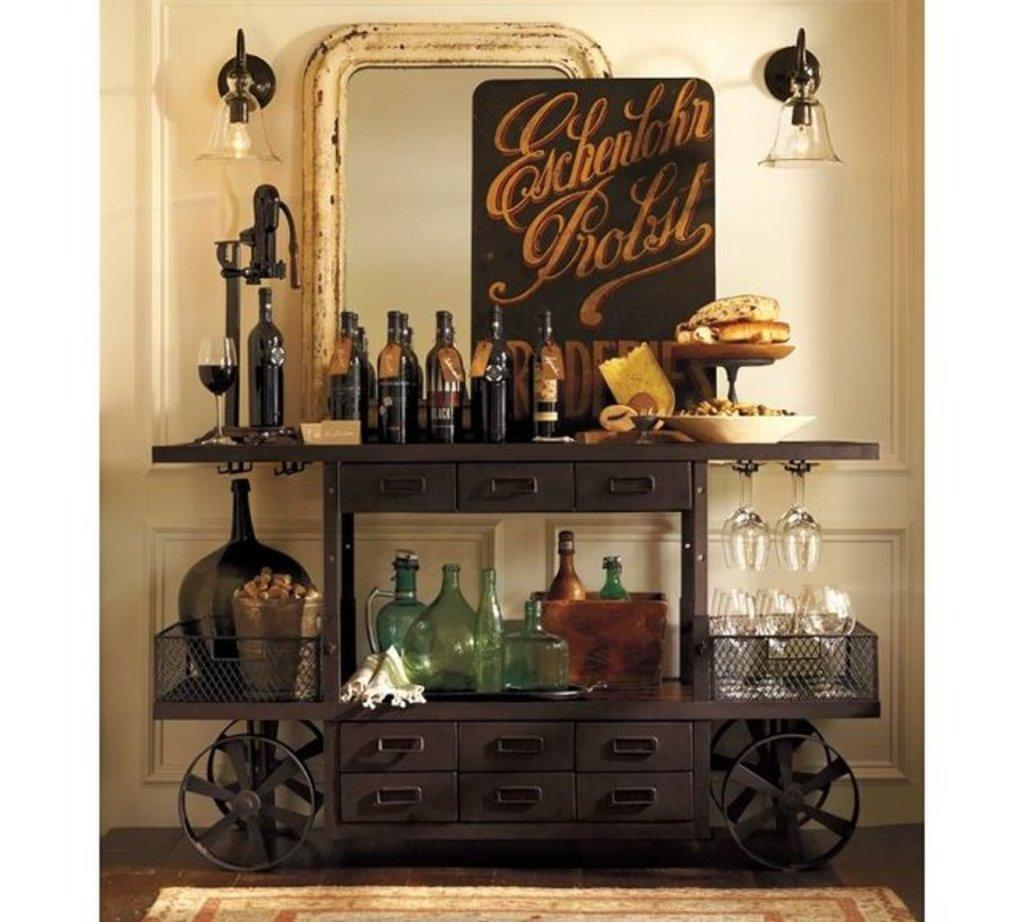Provide a one-sentence caption for the provided image. An Eschenlohr Probst sign sits in front of a mirror. 